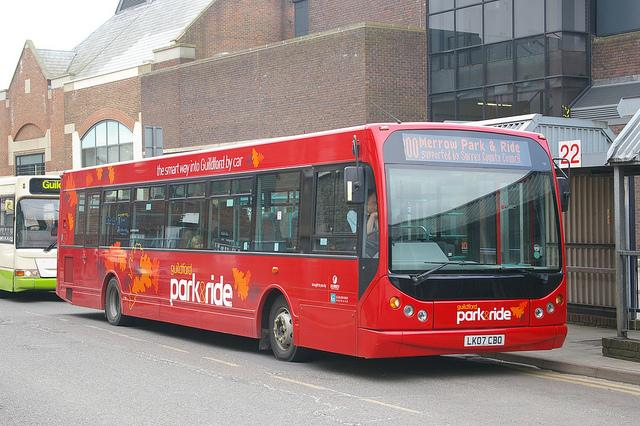What type of transportation is shown? bus 